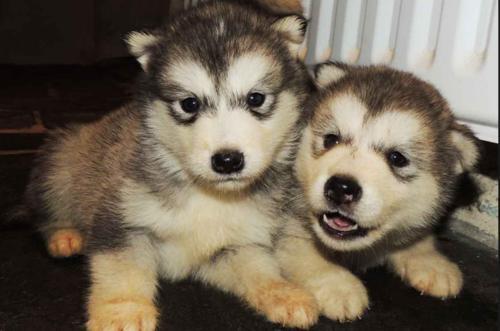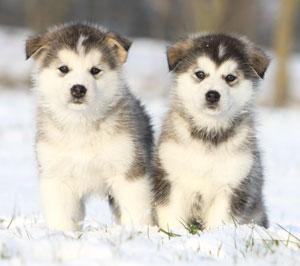The first image is the image on the left, the second image is the image on the right. For the images displayed, is the sentence "The right image features two side-by-side forward-facing puppies with closed mouths." factually correct? Answer yes or no. Yes. The first image is the image on the left, the second image is the image on the right. Considering the images on both sides, is "There is one puppy with black fur, and the other dogs have brown fur." valid? Answer yes or no. No. 